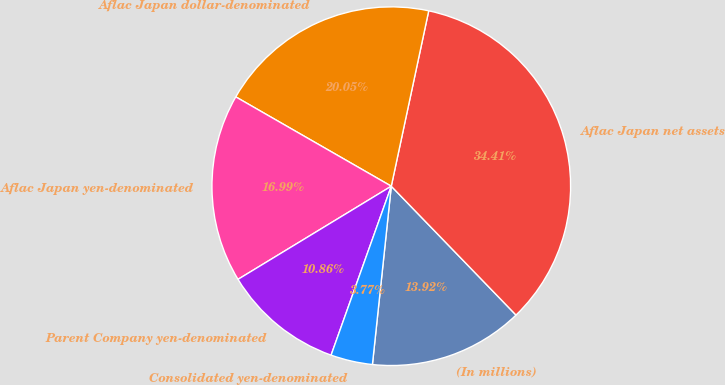<chart> <loc_0><loc_0><loc_500><loc_500><pie_chart><fcel>(In millions)<fcel>Aflac Japan net assets<fcel>Aflac Japan dollar-denominated<fcel>Aflac Japan yen-denominated<fcel>Parent Company yen-denominated<fcel>Consolidated yen-denominated<nl><fcel>13.92%<fcel>34.41%<fcel>20.05%<fcel>16.99%<fcel>10.86%<fcel>3.77%<nl></chart> 